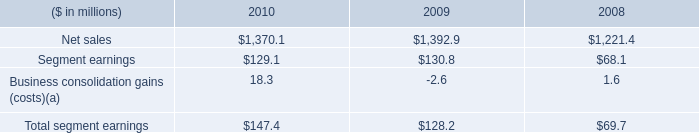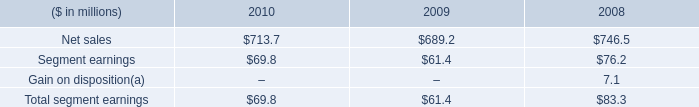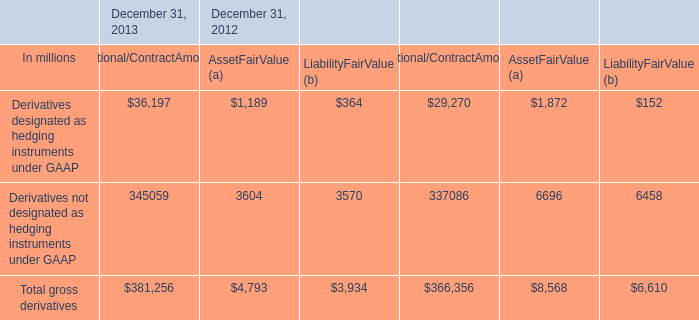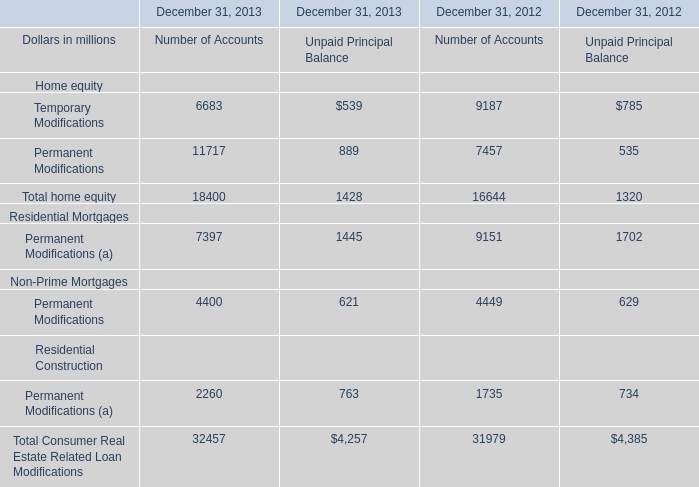What is the total amount of Temporary Modifications of December 31, 2012 Number of Accounts, and Net sales of 2009 ? 
Computations: (9187.0 + 1392.9)
Answer: 10579.9. 